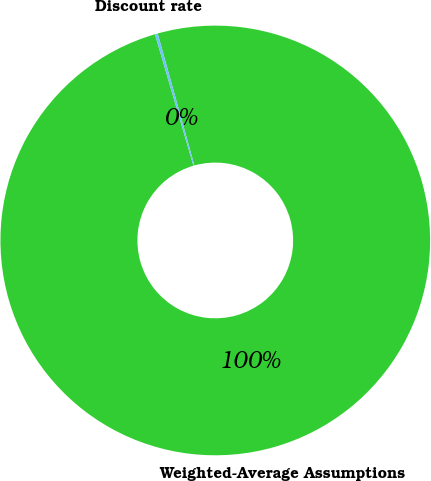Convert chart. <chart><loc_0><loc_0><loc_500><loc_500><pie_chart><fcel>Weighted-Average Assumptions<fcel>Discount rate<nl><fcel>99.79%<fcel>0.21%<nl></chart> 